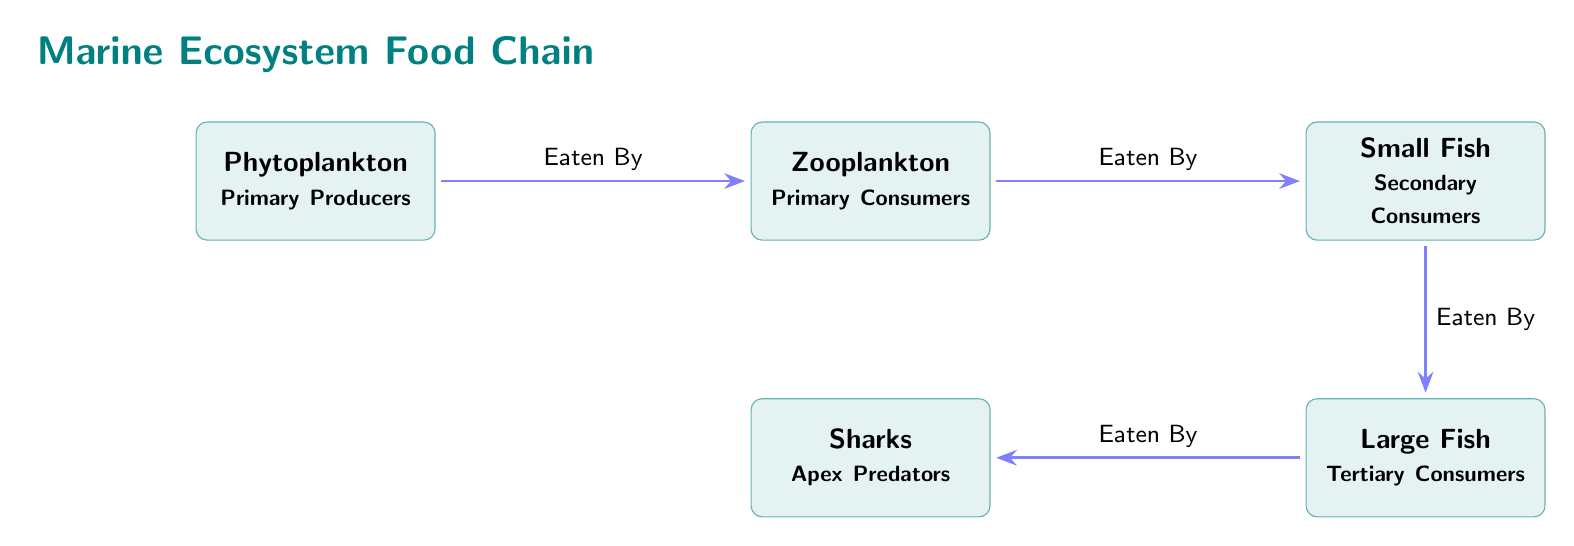What organism is at the top of the food chain? The diagram shows several trophic levels with organisms arranged from primary producers to apex predators. The apex predator, which is at the top of the food chain, is identified as "Sharks."
Answer: Sharks How many organisms are in the food chain? By counting the nodes in the diagram, we find that there are five distinct organisms represented: phytoplankton, zooplankton, small fish, large fish, and sharks.
Answer: Five What type of organism is phytoplankton? The diagram classifies phytoplankton as "Primary Producers," which is indicated directly beneath their name in the diagram.
Answer: Primary Producers Who is eaten by the small fish? The diagram illustrates that small fish are secondary consumers and are eaten by large fish, as indicated by the directed arrow connecting them.
Answer: Large Fish What level of consumer are sharks? Looking at the diagram, sharks are described as "Apex Predators," which categorically places them at the top level of consumers.
Answer: Apex Predators What is the relationship between zooplankton and phytoplankton? The diagram shows an arrow indicating that zooplankton are "Eaten By" phytoplankton, establishing a direct predatory relationship where zooplankton consume phytoplankton.
Answer: Eaten By What is the order of organisms in the food chain starting from primary producers? The diagram shows the flow from phytoplankton to zooplankton, then to small fish, followed by large fish, and finally to sharks, representing the trophic levels sequentially.
Answer: Phytoplankton, Zooplankton, Small Fish, Large Fish, Sharks How many levels of consumers are there in the food chain? The diagram classifies consumers into three levels: primary consumers (zooplankton), secondary consumers (small fish), and tertiary consumers (large fish), resulting in three consumer levels.
Answer: Three Which organism is classified as secondary consumers? In the diagram, "Small Fish" are specifically labeled as secondary consumers, making them the organism at this level in the food chain.
Answer: Small Fish 